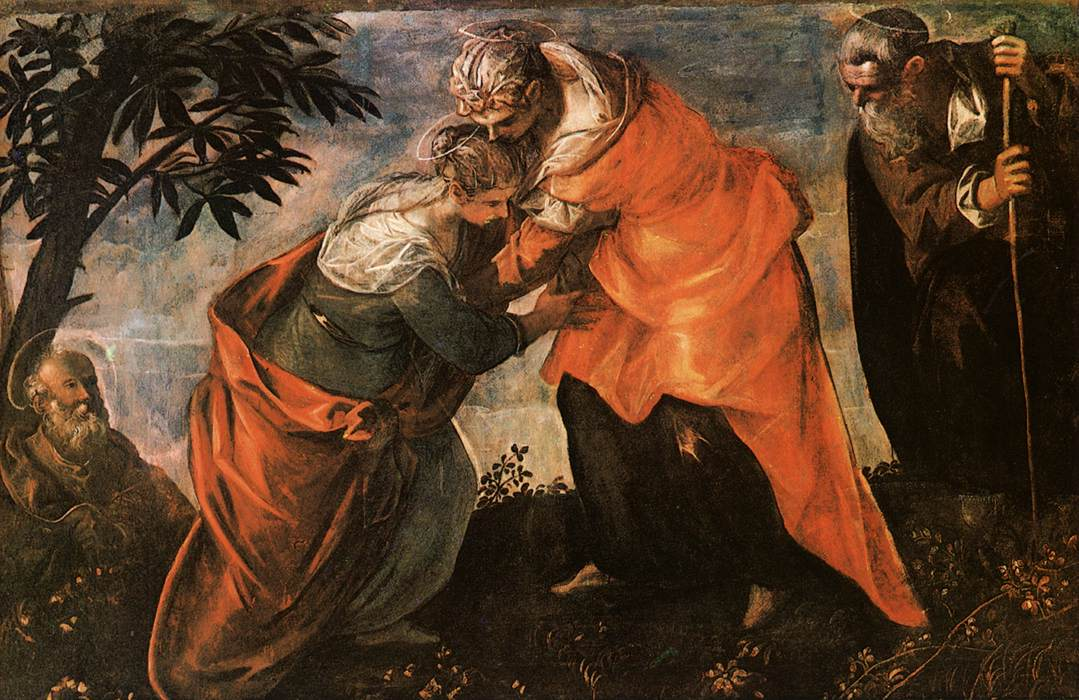What do you think is going on in this snapshot? The image depicts an oil painting of the Visitation, a Biblical scene where Mary visits her cousin Elizabeth. Both figures are central, their reunion marked by a gesture of greeting and warmth. This artwork is a fine representation of the Italian Renaissance era, noted for its lifelike figures and detailed landscapes. The characters are dressed in flowing robes, likely made of rich fabrics, a common trait in depictions from this period. The vibrant use of color and the delicate rendering of the garden setting, with trees subtly framing the figures, enhances the emotional and spiritual significance of the scene. To appreciate this piece fully, understanding the artist's motivations and the historical context during which it was painted could provide deeper insights into its religious and artistic importance. 